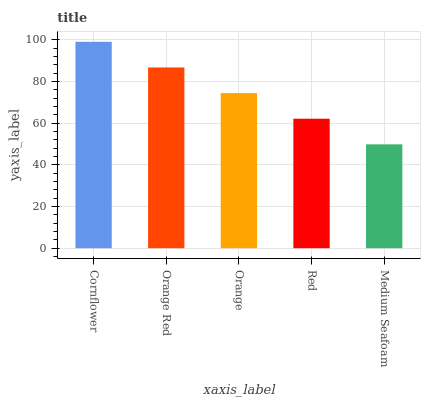Is Medium Seafoam the minimum?
Answer yes or no. Yes. Is Cornflower the maximum?
Answer yes or no. Yes. Is Orange Red the minimum?
Answer yes or no. No. Is Orange Red the maximum?
Answer yes or no. No. Is Cornflower greater than Orange Red?
Answer yes or no. Yes. Is Orange Red less than Cornflower?
Answer yes or no. Yes. Is Orange Red greater than Cornflower?
Answer yes or no. No. Is Cornflower less than Orange Red?
Answer yes or no. No. Is Orange the high median?
Answer yes or no. Yes. Is Orange the low median?
Answer yes or no. Yes. Is Orange Red the high median?
Answer yes or no. No. Is Orange Red the low median?
Answer yes or no. No. 